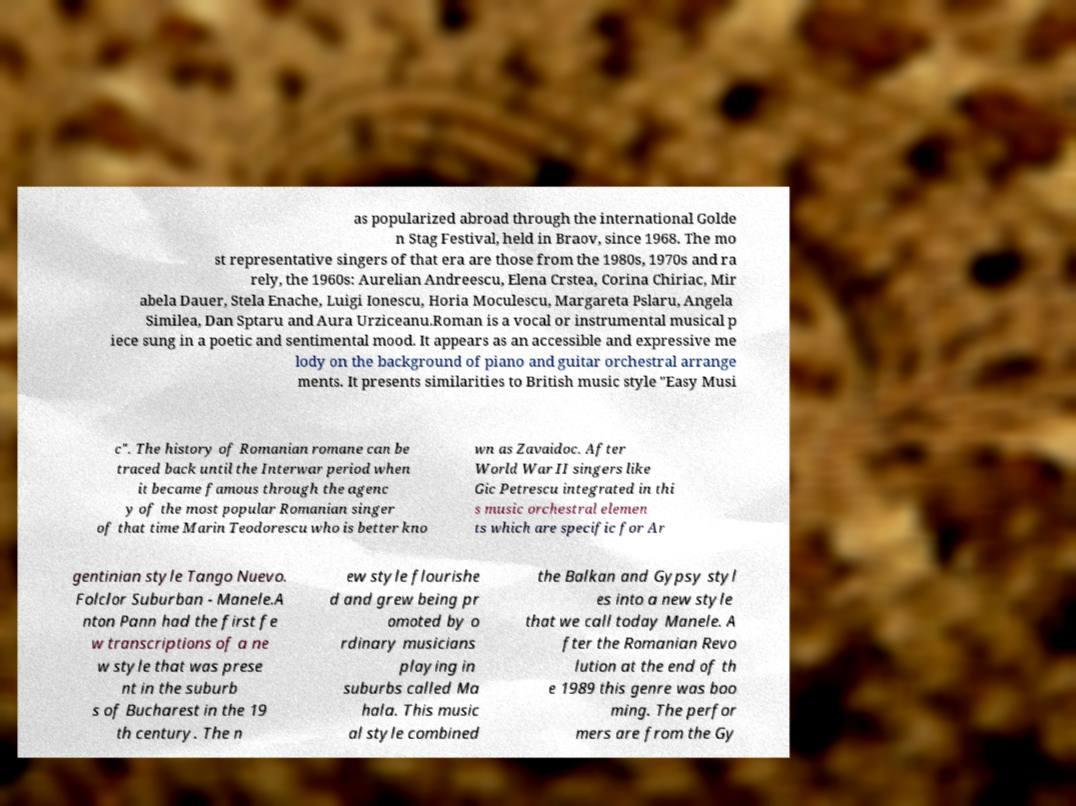What messages or text are displayed in this image? I need them in a readable, typed format. as popularized abroad through the international Golde n Stag Festival, held in Braov, since 1968. The mo st representative singers of that era are those from the 1980s, 1970s and ra rely, the 1960s: Aurelian Andreescu, Elena Crstea, Corina Chiriac, Mir abela Dauer, Stela Enache, Luigi Ionescu, Horia Moculescu, Margareta Pslaru, Angela Similea, Dan Sptaru and Aura Urziceanu.Roman is a vocal or instrumental musical p iece sung in a poetic and sentimental mood. It appears as an accessible and expressive me lody on the background of piano and guitar orchestral arrange ments. It presents similarities to British music style "Easy Musi c". The history of Romanian romane can be traced back until the Interwar period when it became famous through the agenc y of the most popular Romanian singer of that time Marin Teodorescu who is better kno wn as Zavaidoc. After World War II singers like Gic Petrescu integrated in thi s music orchestral elemen ts which are specific for Ar gentinian style Tango Nuevo. Folclor Suburban - Manele.A nton Pann had the first fe w transcriptions of a ne w style that was prese nt in the suburb s of Bucharest in the 19 th century. The n ew style flourishe d and grew being pr omoted by o rdinary musicians playing in suburbs called Ma hala. This music al style combined the Balkan and Gypsy styl es into a new style that we call today Manele. A fter the Romanian Revo lution at the end of th e 1989 this genre was boo ming. The perfor mers are from the Gy 